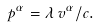Convert formula to latex. <formula><loc_0><loc_0><loc_500><loc_500>p ^ { \alpha } = \lambda \, v ^ { \alpha } / c .</formula> 